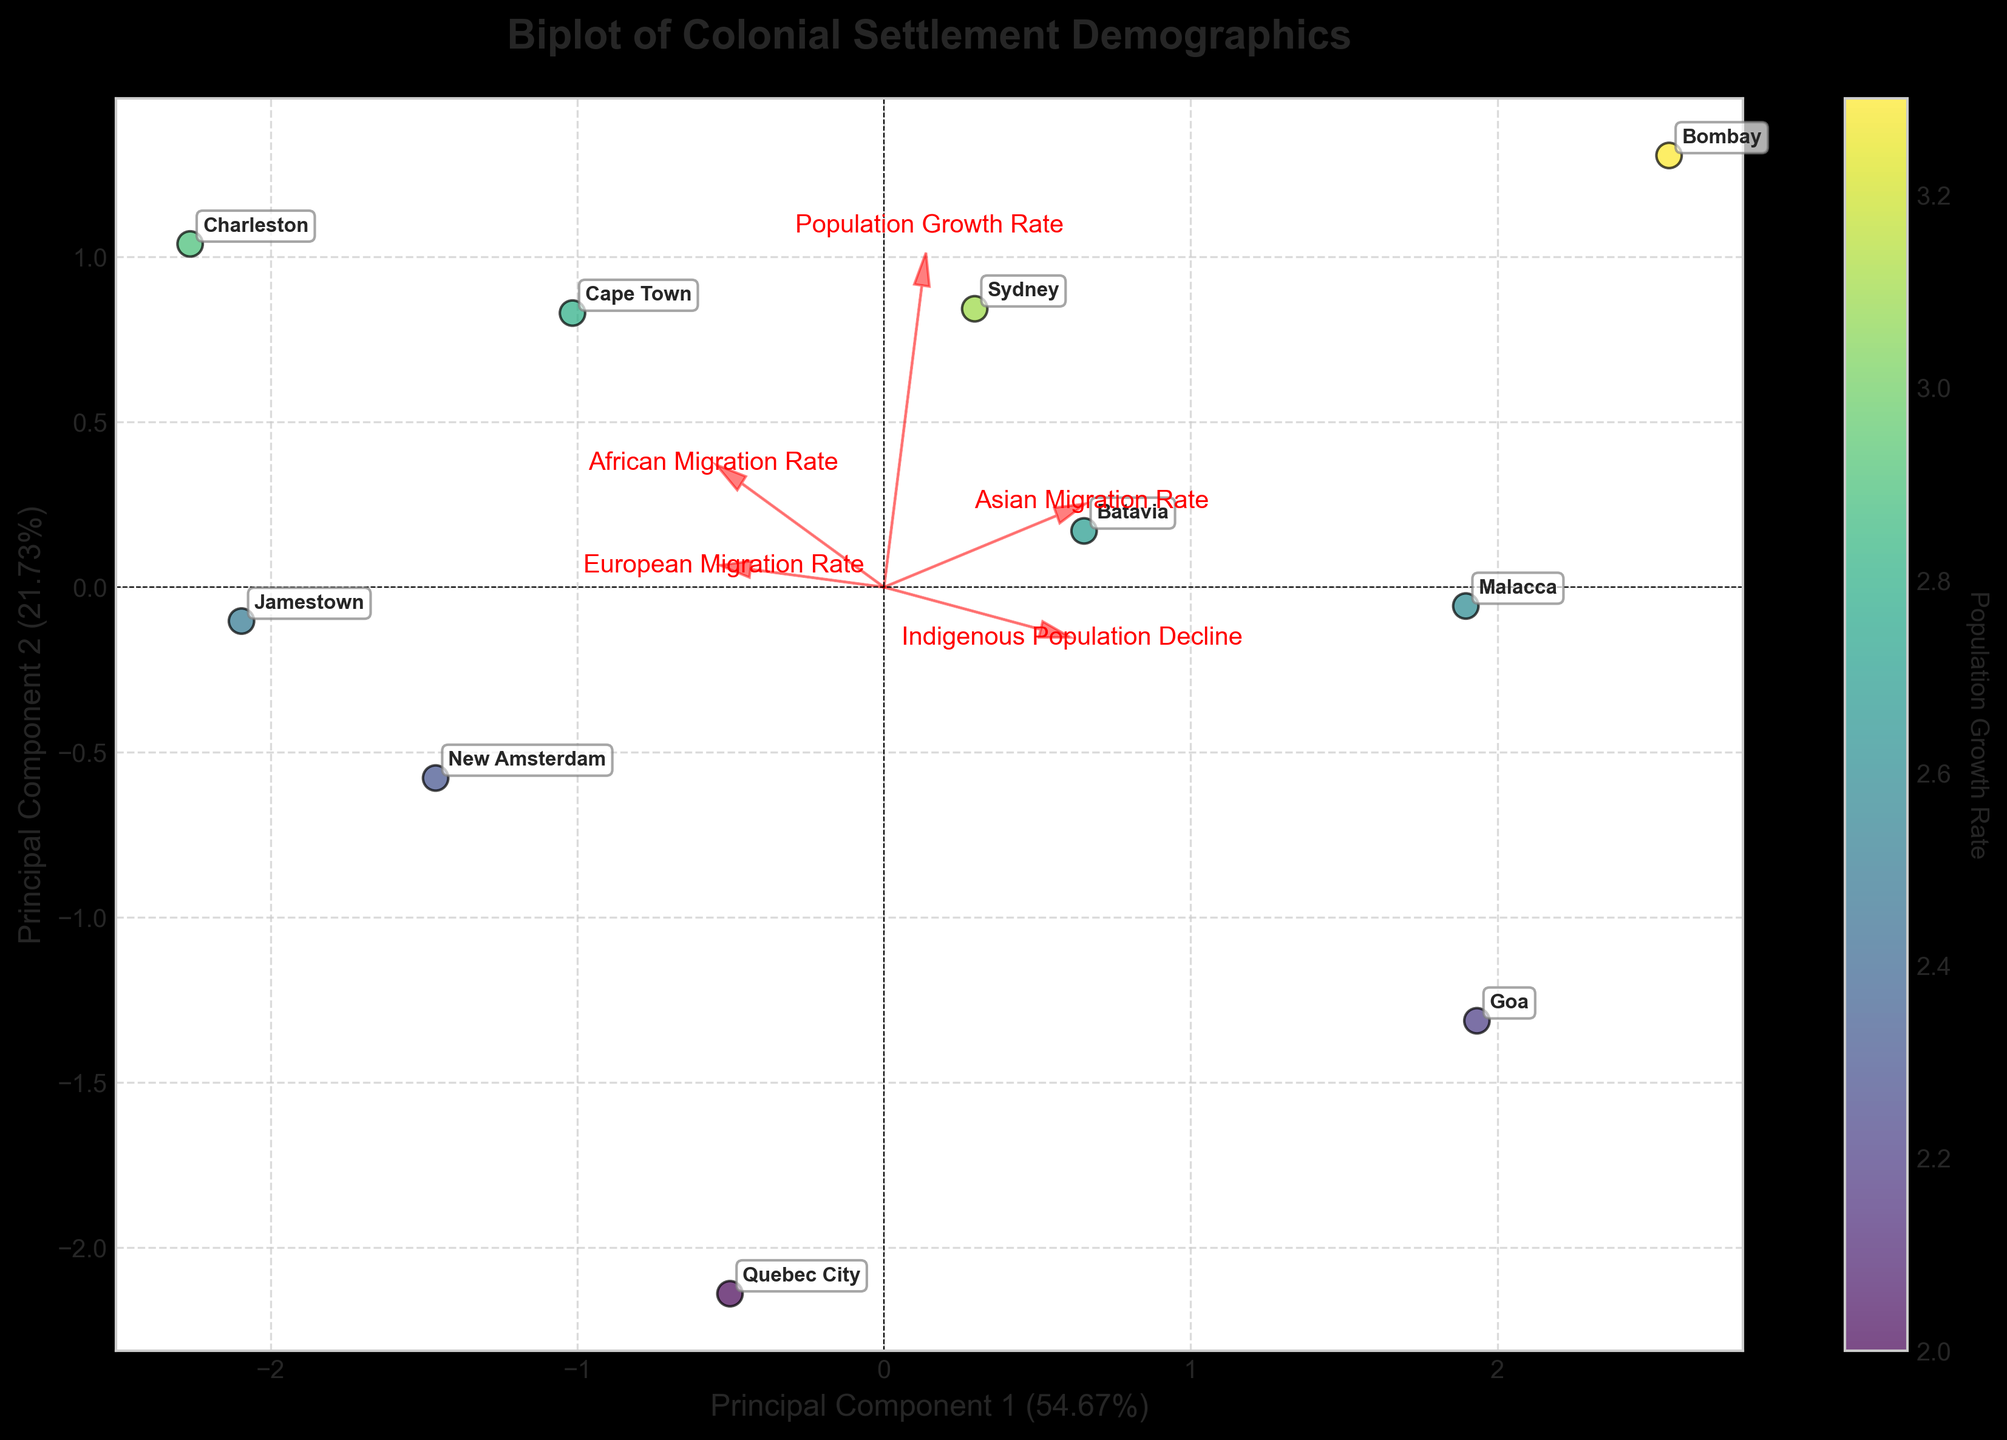What is the title of the figure? The title of the figure is typically displayed at the top of a chart or plot.
Answer: Biplot of Colonial Settlement Demographics How many lines represent feature vectors in the biplot? Feature vectors are represented by arrows emanating from the origin in a biplot. Each arrow corresponds to one of the features in the dataset. Count the number of arrows.
Answer: Five Which settlement has the highest color intensity on the plot? The color intensity in the scatter plot represents the Population Growth Rate. The settlement with the most intense color (highest value) can be identified visually on the plot.
Answer: Bombay How many principal components are shown in the biplot? The number of principal components in a biplot is usually depicted by the axes labeled as Principal Component 1 and Principal Component 2.
Answer: Two Which feature vector has the highest loading on the Principal Component 1 axis? The loading of a feature on Principal Component 1 can be determined by the length of the arrow and its projection on the Principal Component 1 axis. The feature vector with the longest arrow in the direction of the Principal Component 1 axis has the highest loading.
Answer: European Migration Rate Which settlements are closest to each other in the biplot and may be considered similar in terms of the represented features? Settlements that are plotted close to each other in the biplot have similar values for the plotted features. Identify any clusters or pairs of closely located settlements in the plot.
Answer: Cape Town and Charleston What is the explained variance of the first principal component? The explained variance of the first principal component is usually indicated on the label of the Principal Component 1 axis in percentage form. It tells how much of the total variance is captured by the first component.
Answer: This value depends on the actual variance explained, check the label of the PC1 axis on the plot Which feature vector is nearly orthogonal to the African Migration Rate vector, indicating a low correlation? Orthogonality in a biplot suggests a low or zero correlation between features. Identify the feature vector that forms nearly a 90-degree angle (right angle) with the African Migration Rate vector.
Answer: Indigenous Population Decline What does the color bar in the plot represent? The color bar in the plot usually indicates the variable whose different values are represented by various colors on the plot.
Answer: Population Growth Rate Which settlement has the lowest indigenous population decline rate based on its position on the plot? This can be interpreted by looking at the direction and length of the Indigenous Population Decline vector and identifying which settlement falls closest to the low end of this feature.
Answer: Bombay 